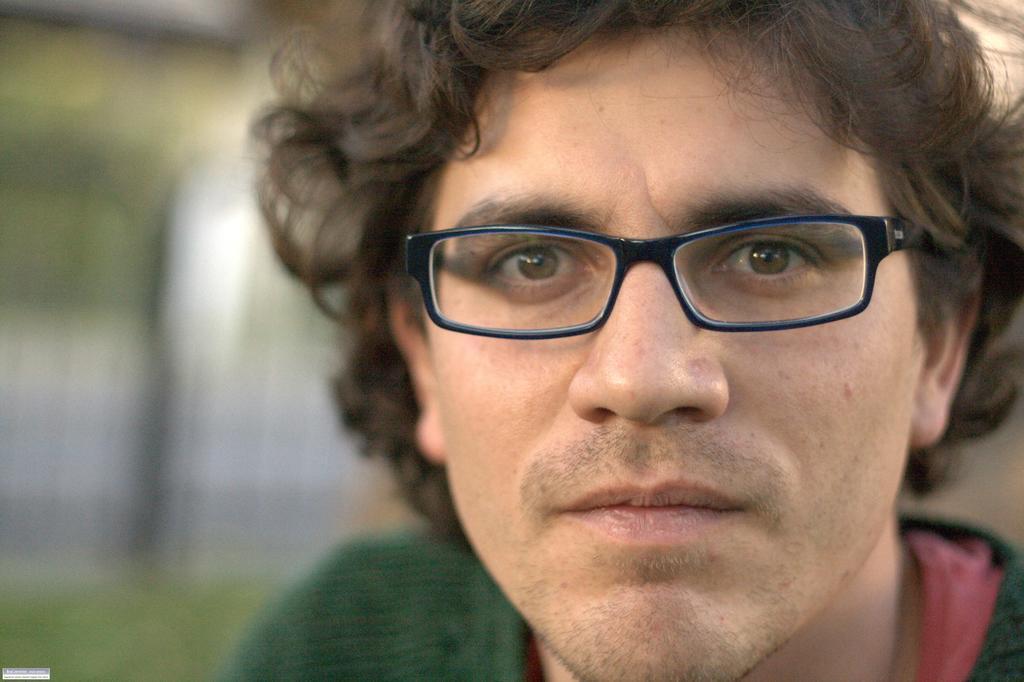Can you describe this image briefly? In the foreground of this picture, there is a man in green T shirt and spectacles and the background is blurred. 